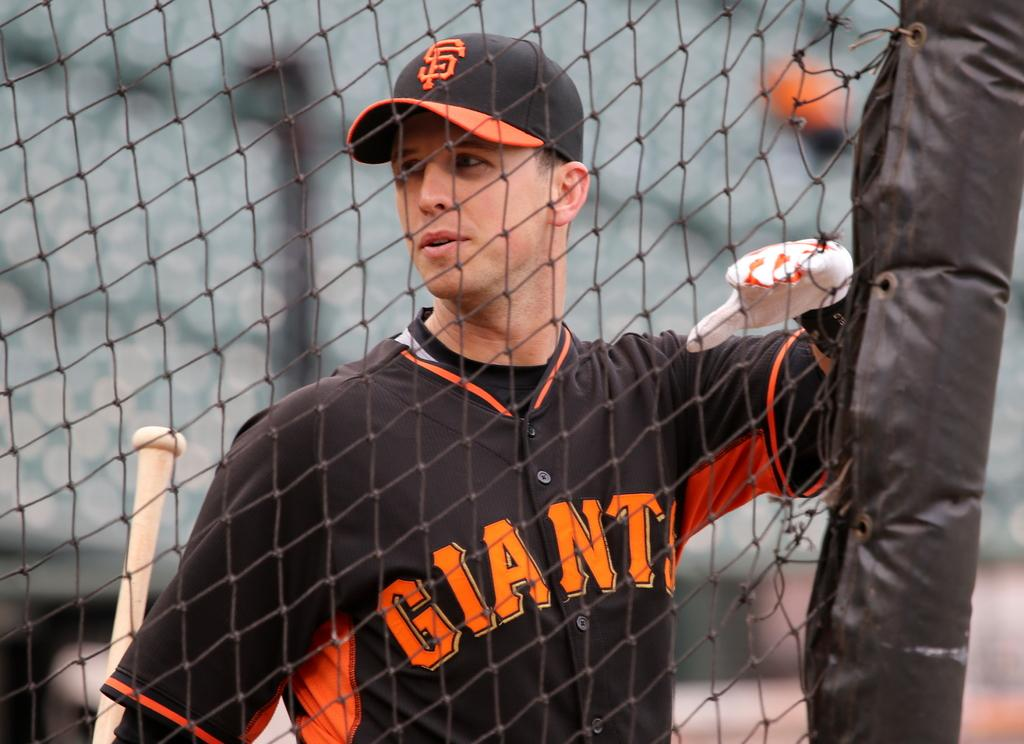<image>
Render a clear and concise summary of the photo. Baseball player standing in front of a fence with a giant jersey 